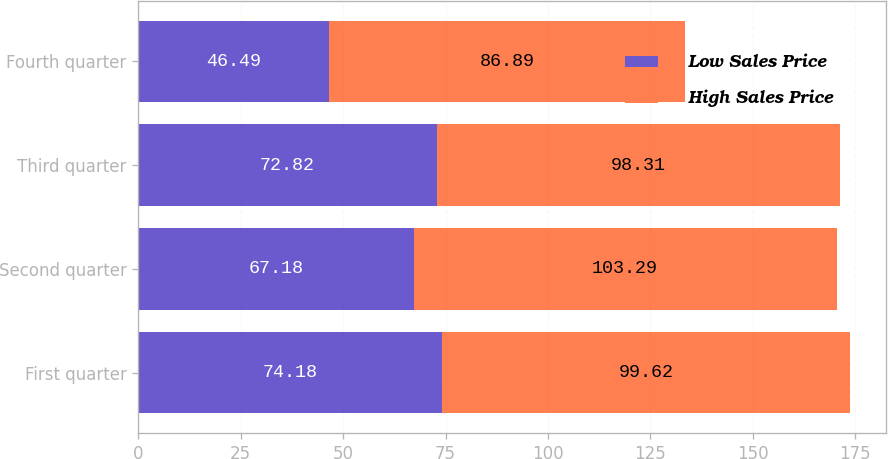Convert chart. <chart><loc_0><loc_0><loc_500><loc_500><stacked_bar_chart><ecel><fcel>First quarter<fcel>Second quarter<fcel>Third quarter<fcel>Fourth quarter<nl><fcel>Low Sales Price<fcel>74.18<fcel>67.18<fcel>72.82<fcel>46.49<nl><fcel>High Sales Price<fcel>99.62<fcel>103.29<fcel>98.31<fcel>86.89<nl></chart> 